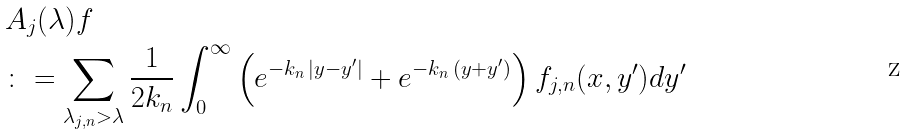<formula> <loc_0><loc_0><loc_500><loc_500>& A _ { j } ( \lambda ) f \\ & \colon = \sum _ { \lambda _ { j , n } > \lambda } \frac { 1 } { 2 k _ { n } } \int _ { 0 } ^ { \infty } \left ( e ^ { - k _ { n } \, | y - y ^ { \prime } | } + e ^ { - k _ { n } \, ( y + y ^ { \prime } ) } \right ) f _ { j , n } ( x , y ^ { \prime } ) d y ^ { \prime }</formula> 